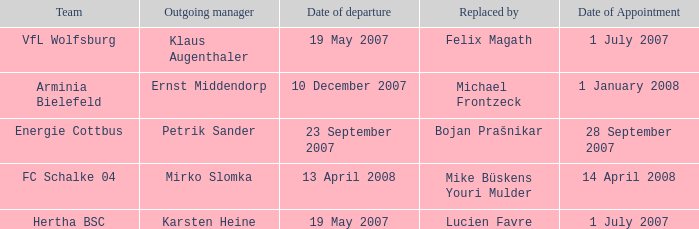When is the appointment date for outgoing manager Petrik Sander? 28 September 2007. 